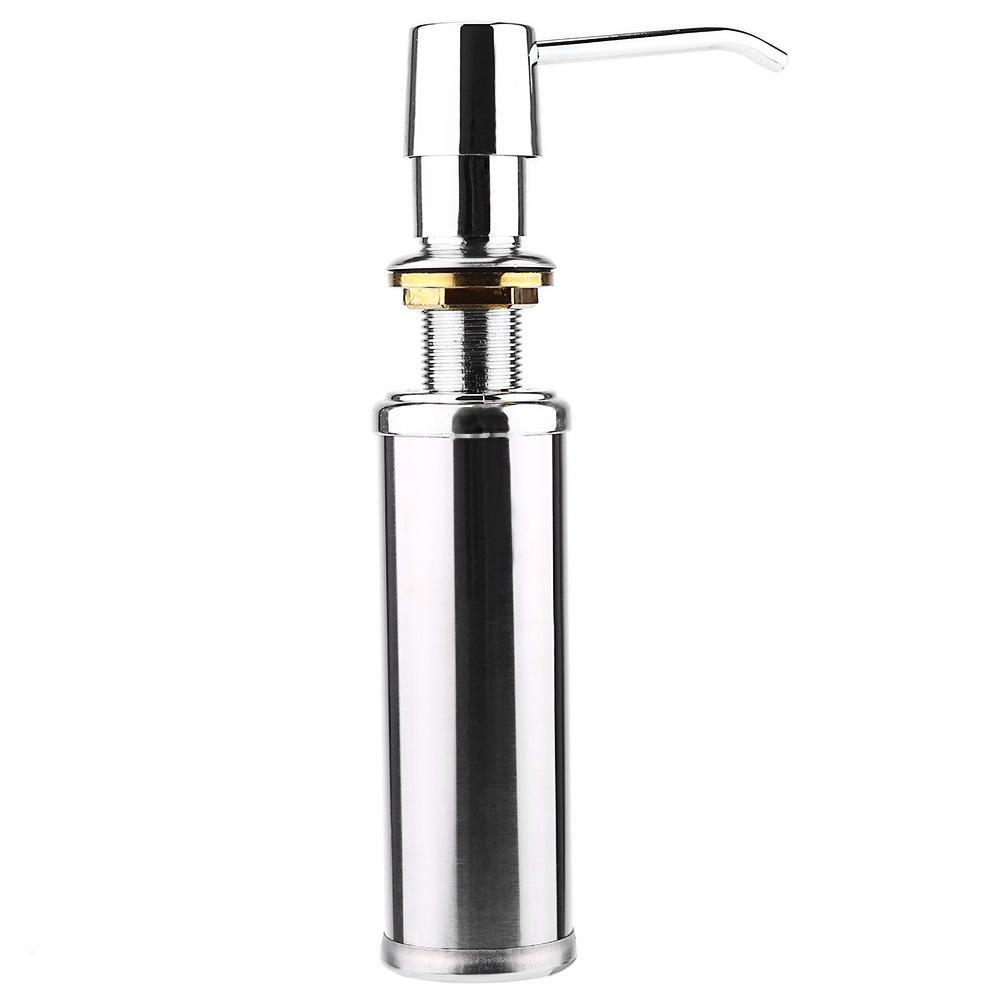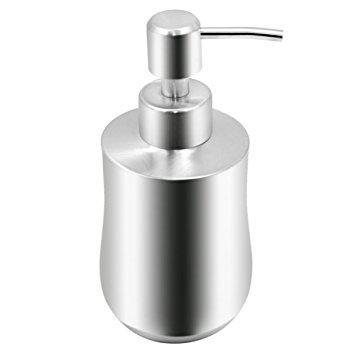The first image is the image on the left, the second image is the image on the right. Analyze the images presented: Is the assertion "The pump spigots are all facing to the left." valid? Answer yes or no. No. 